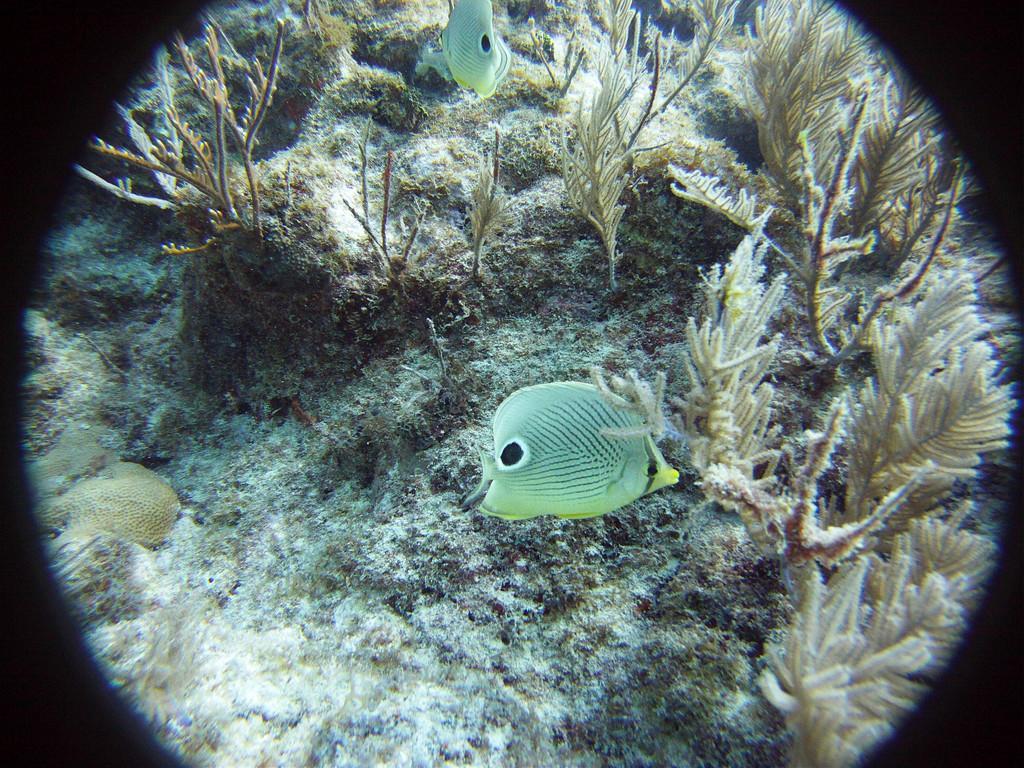In one or two sentences, can you explain what this image depicts? In this picture, we see the fishes are swimming in the water. Beside that, we see the aquatic plants. This picture might be clicked in the aquarium or in the sea. On either side of the picture, it is black in color and this might be an edited image. 